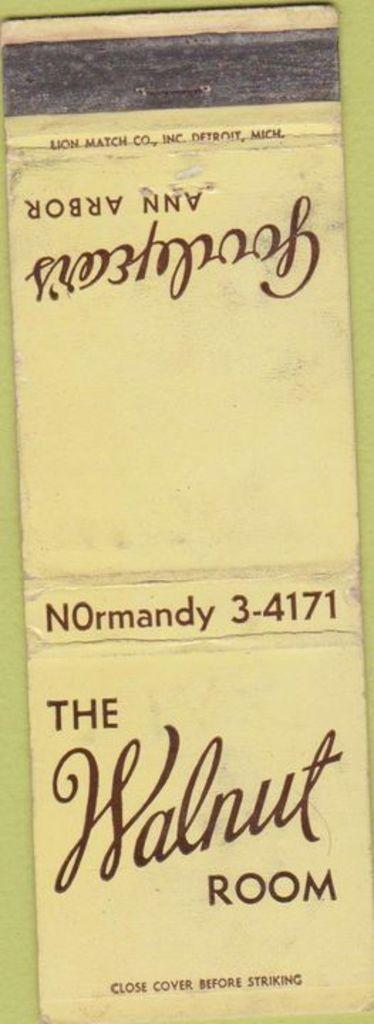<image>
Present a compact description of the photo's key features. An old paper matchbook from The Walnut Room in Normandy. 